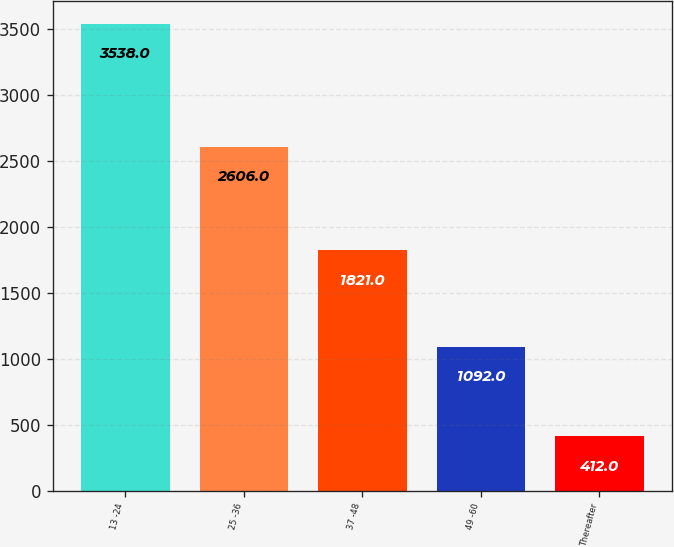Convert chart to OTSL. <chart><loc_0><loc_0><loc_500><loc_500><bar_chart><fcel>13 -24<fcel>25 -36<fcel>37 -48<fcel>49 -60<fcel>Thereafter<nl><fcel>3538<fcel>2606<fcel>1821<fcel>1092<fcel>412<nl></chart> 